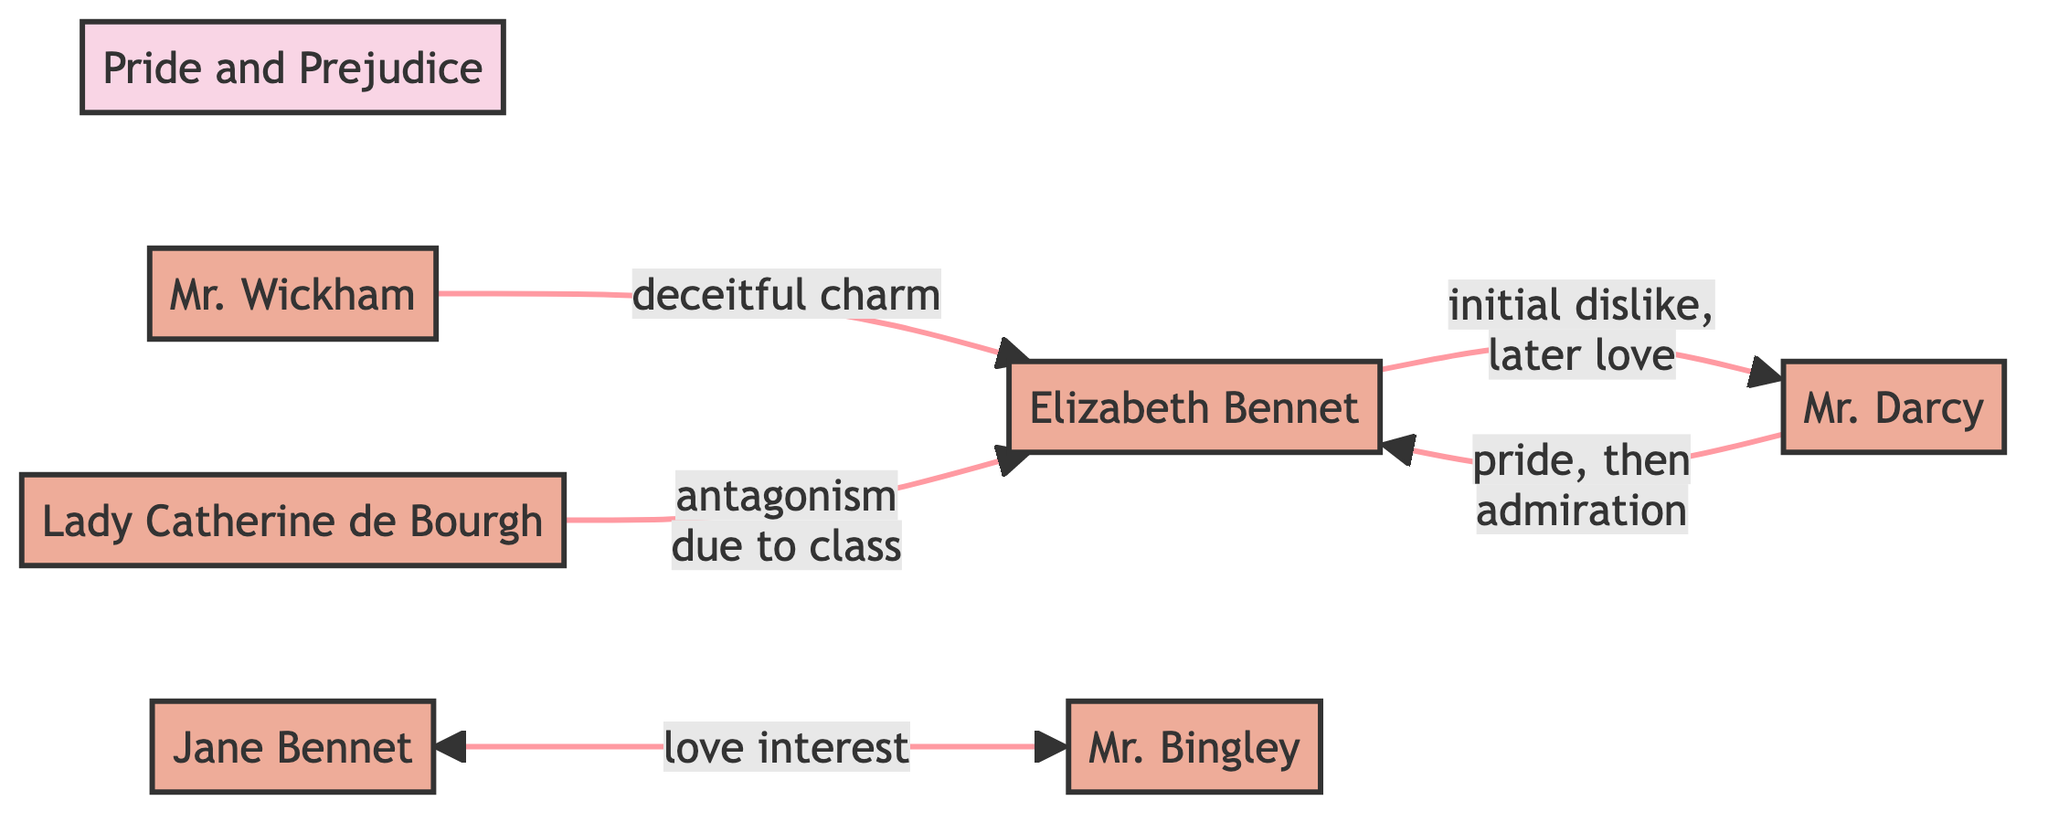What is the title of the novel depicted in the diagram? The diagram includes a main node labeled "Pride and Prejudice," which indicates the title of the novel being represented.
Answer: Pride and Prejudice How many characters are depicted in the diagram? The diagram contains six distinct character nodes: Elizabeth Bennet, Mr. Darcy, Mr. Bingley, Jane Bennet, Mr. Wickham, and Lady Catherine de Bourgh. Counting these nodes gives us the total character count.
Answer: 6 What is the relationship between Elizabeth Bennet and Mr. Darcy? The directed edge from Elizabeth Bennet to Mr. Darcy is labeled "initial dislike, later love," indicating the nature of their relationship, while the opposite edge indicates "pride, then admiration" from Mr. Darcy to Elizabeth.
Answer: initial dislike, later love Which character is associated with the label "deceitful charm"? The diagram shows a directed edge from Mr. Wickham to Elizabeth Bennet, labelled "deceitful charm," signifying that Mr. Wickham is characterized this way in relation to Elizabeth.
Answer: Mr. Wickham What type of relationship exists between Jane Bennet and Mr. Bingley? The diagram indicates a bidirectional relationship between Jane Bennet and Mr. Bingley, both labelled as "love interest." This shows a mutual connection characterized by romantic interest.
Answer: love interest What is the nature of the antagonism Lady Catherine has towards Elizabeth Bennet? A directed edge connects Lady Catherine to Elizabeth Bennet and is labelled "antagonism due to class," pinpointing the reason for their antagonistic relationship.
Answer: antagonism due to class How many edges are present in the diagram? The edges represent relationships between the characters. Counting all the directed edges shown in the diagram gives a total of five distinct edges connecting various character pairs.
Answer: 5 What does the label on the edge from Mr. Darcy to Elizabeth Bennet signify? The directed edge from Mr. Darcy to Elizabeth Bennet is labelled "pride, then admiration," which describes Mr. Darcy’s evolving feelings towards Elizabeth throughout the novel.
Answer: pride, then admiration Who is the main antagonist towards Elizabeth Bennet in terms of social class? The diagram clearly shows that Lady Catherine, connected to Elizabeth Bennet with a directed edge labelled "antagonism due to class," plays the role of the antagonist with respect to Elizabeth's social standing.
Answer: Lady Catherine 